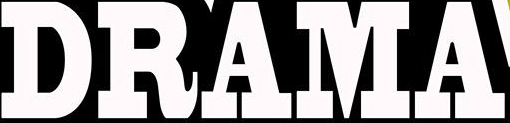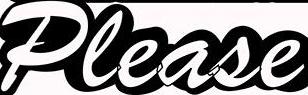What text is displayed in these images sequentially, separated by a semicolon? DRAMA; Please 